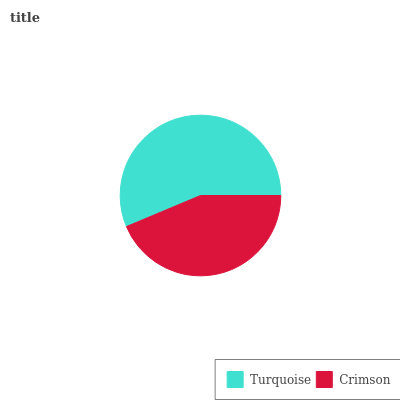Is Crimson the minimum?
Answer yes or no. Yes. Is Turquoise the maximum?
Answer yes or no. Yes. Is Crimson the maximum?
Answer yes or no. No. Is Turquoise greater than Crimson?
Answer yes or no. Yes. Is Crimson less than Turquoise?
Answer yes or no. Yes. Is Crimson greater than Turquoise?
Answer yes or no. No. Is Turquoise less than Crimson?
Answer yes or no. No. Is Turquoise the high median?
Answer yes or no. Yes. Is Crimson the low median?
Answer yes or no. Yes. Is Crimson the high median?
Answer yes or no. No. Is Turquoise the low median?
Answer yes or no. No. 